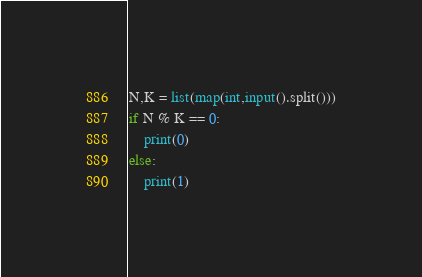Convert code to text. <code><loc_0><loc_0><loc_500><loc_500><_Python_>N,K = list(map(int,input().split()))
if N % K == 0:
    print(0)
else:
    print(1)</code> 